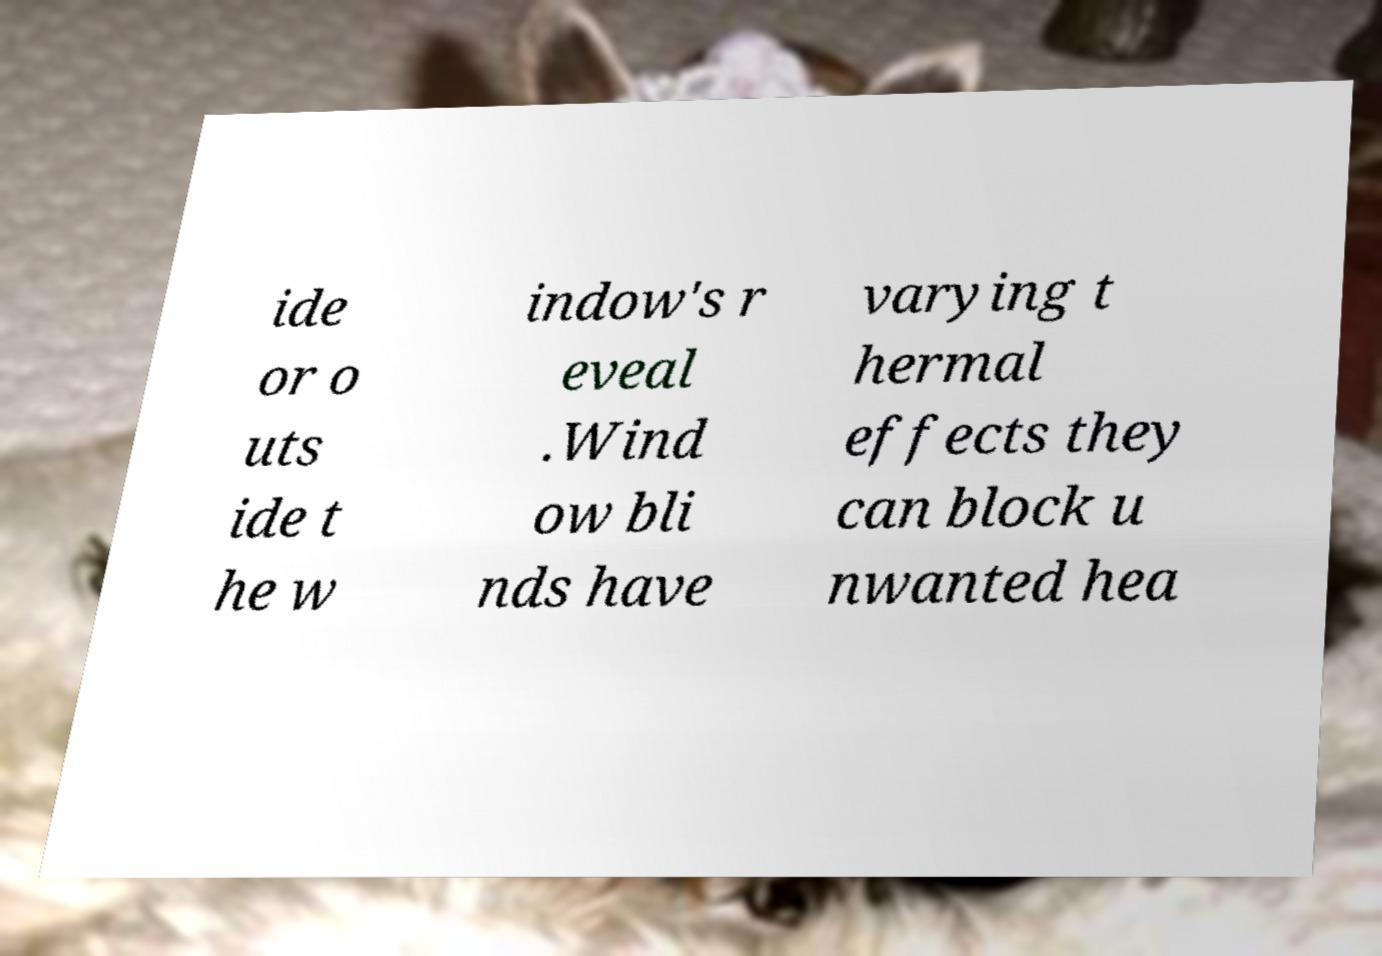Please read and relay the text visible in this image. What does it say? ide or o uts ide t he w indow's r eveal .Wind ow bli nds have varying t hermal effects they can block u nwanted hea 